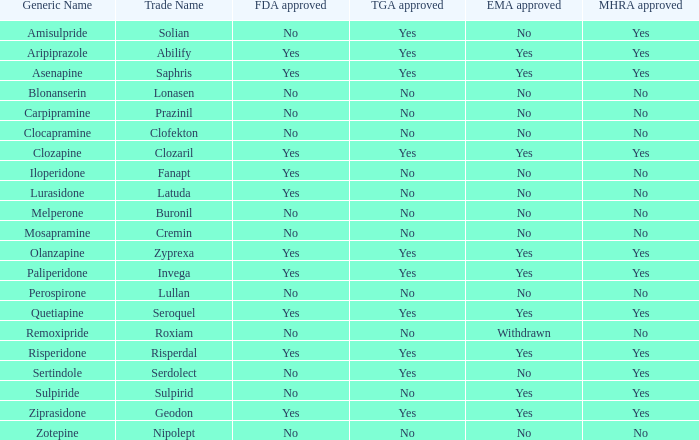Is blonanserin sanctioned by mhra? No. 